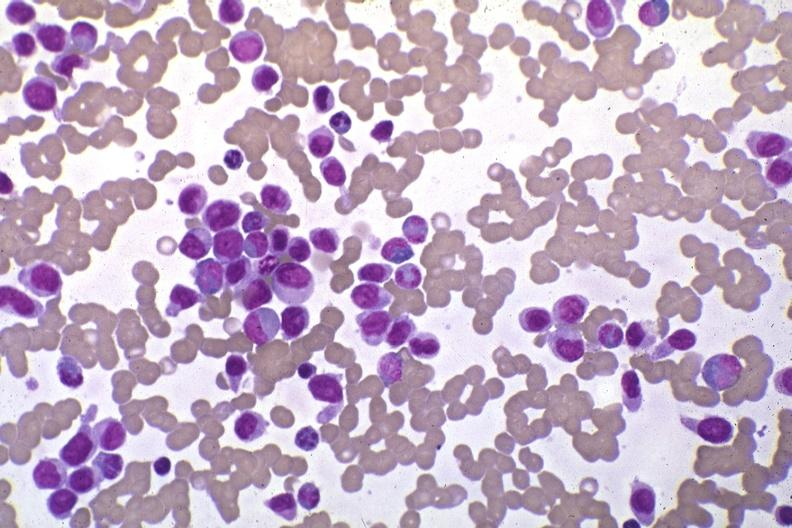s gaucher cell present?
Answer the question using a single word or phrase. No 